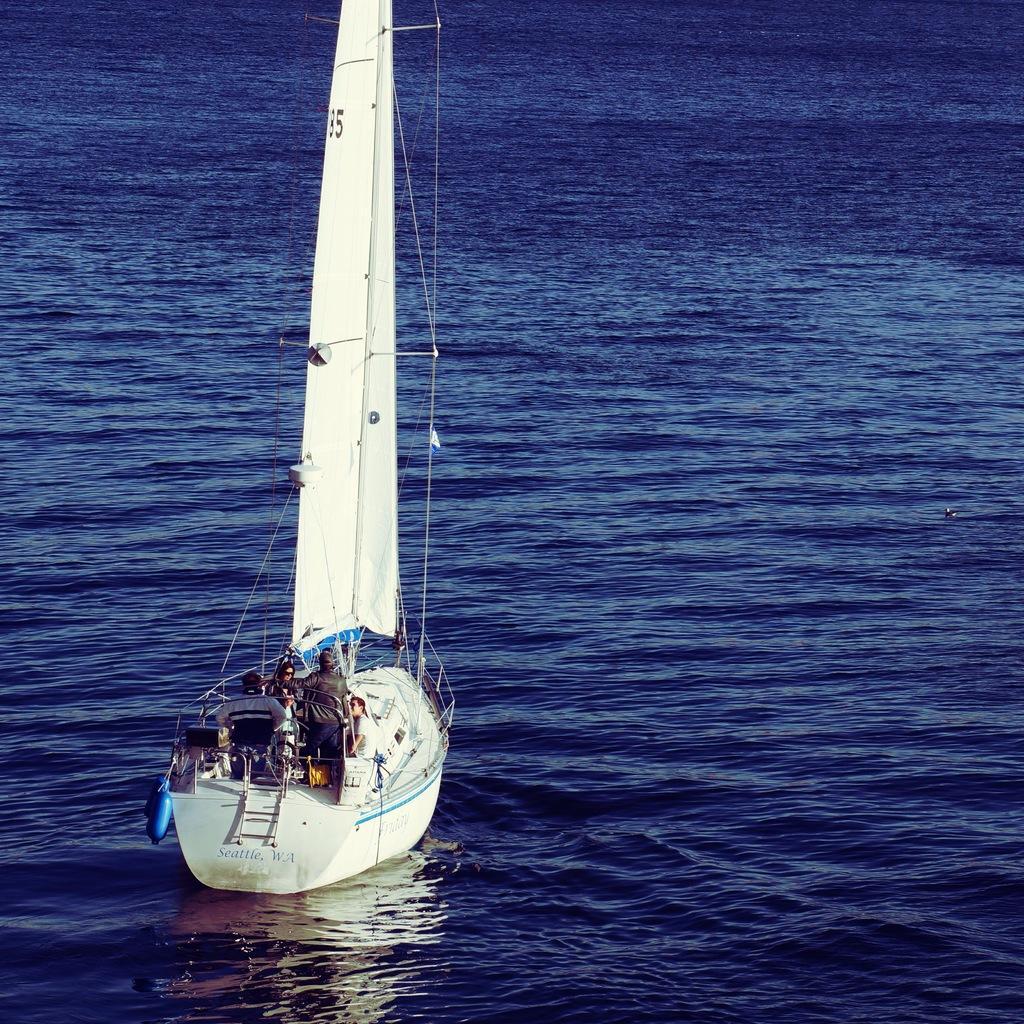Could you give a brief overview of what you see in this image? In this image there is a boat and water. In the boat there are people and objects.   